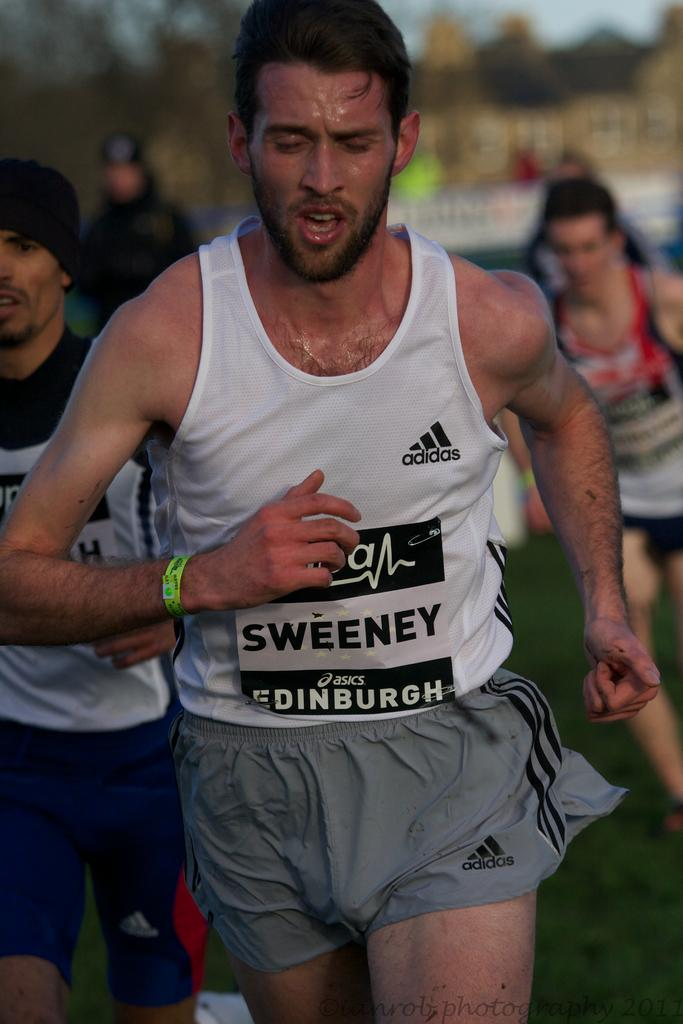<image>
Write a terse but informative summary of the picture. Man running in a track and field event, his shirt says Sweeney Asics Edinburgh. 